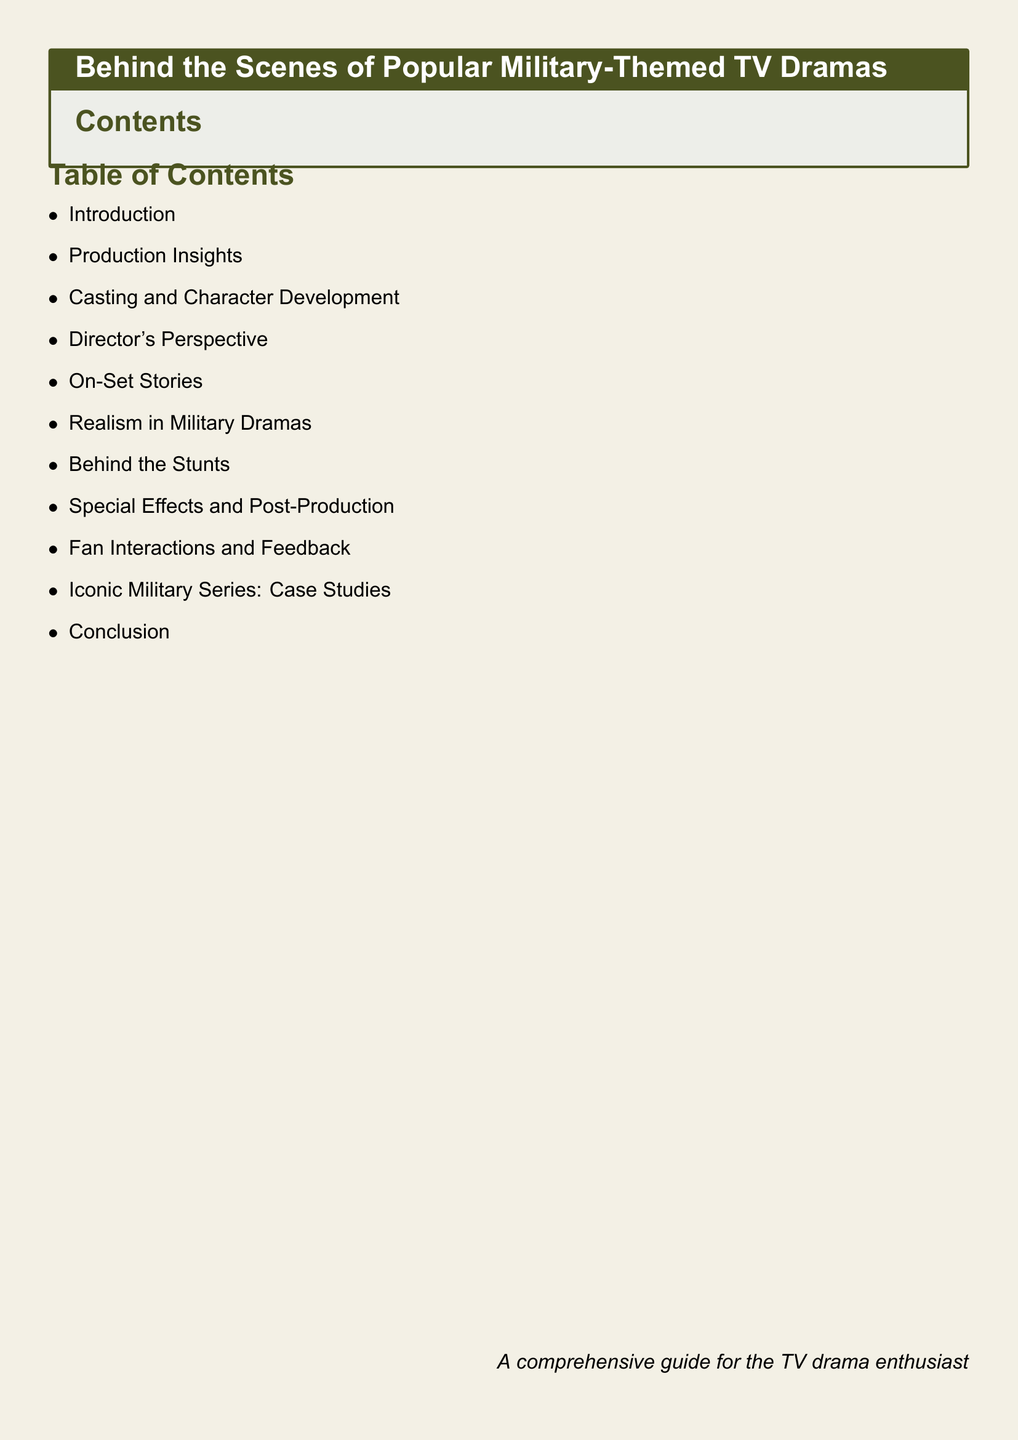What is the title of the document? The title is presented in the tcolorbox at the beginning of the document.
Answer: Behind the Scenes of Popular Military-Themed TV Dramas How many main sections are in the Table of Contents? The document lists the main sections in the Table of Contents, and they can be counted.
Answer: 10 What section discusses fan interactions? The Table of Contents provides section titles, one of which specifically mentions fan interactions.
Answer: Fan Interactions and Feedback Which section focuses on the director's insights? The section dedicated to the director's viewpoint is mentioned explicitly in the Table of Contents.
Answer: Director's Perspective What is the purpose of the document stated at the end? The phrase at the bottom summarizes the overall intent of the document for the audience.
Answer: A comprehensive guide for the TV drama enthusiast What color is used for the section titles? The formatting and color specifications for the titles are defined at the beginning, reflecting the chosen aesthetic.
Answer: Military green 